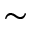<formula> <loc_0><loc_0><loc_500><loc_500>\sim</formula> 